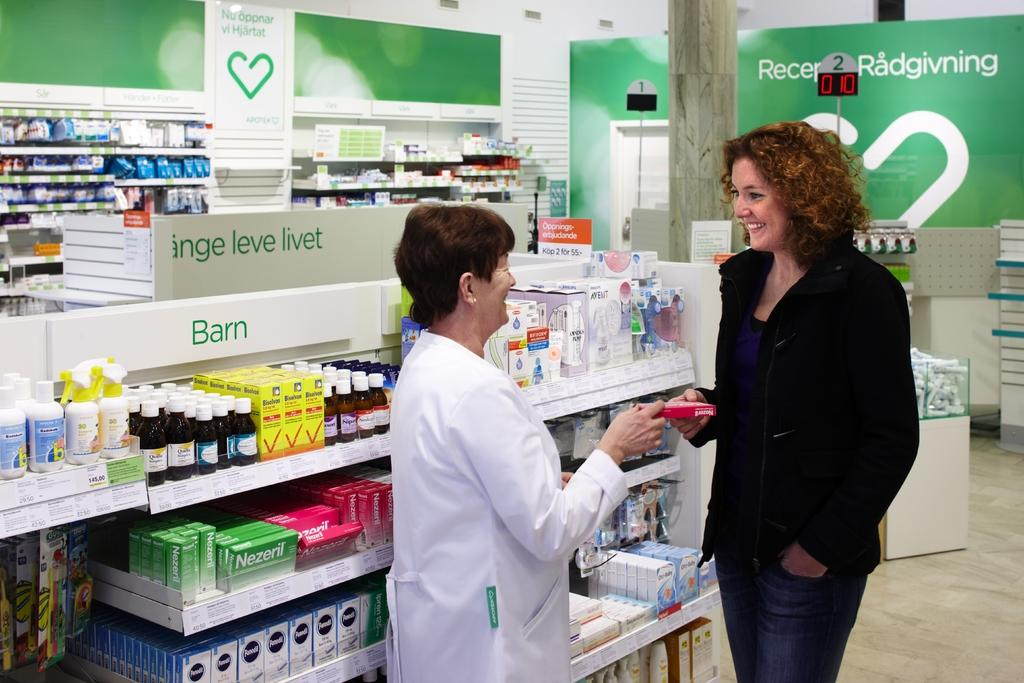How many women are in the image? There are two women standing in the image. What are the women holding in the image? The women are holding a box. What other items can be seen in the image besides the women and the box? There are bottles, boxes, and objects in racks visible in the image. What can be seen in the background of the image? There is a pillar, a board, and a wall in the background of the image. Are there any objects in racks in the background of the image? Yes, there are objects in racks in the background of the image. What type of weather can be seen in the image? The image does not show any weather conditions; it is an indoor scene with a wall, pillar, and board in the background. 